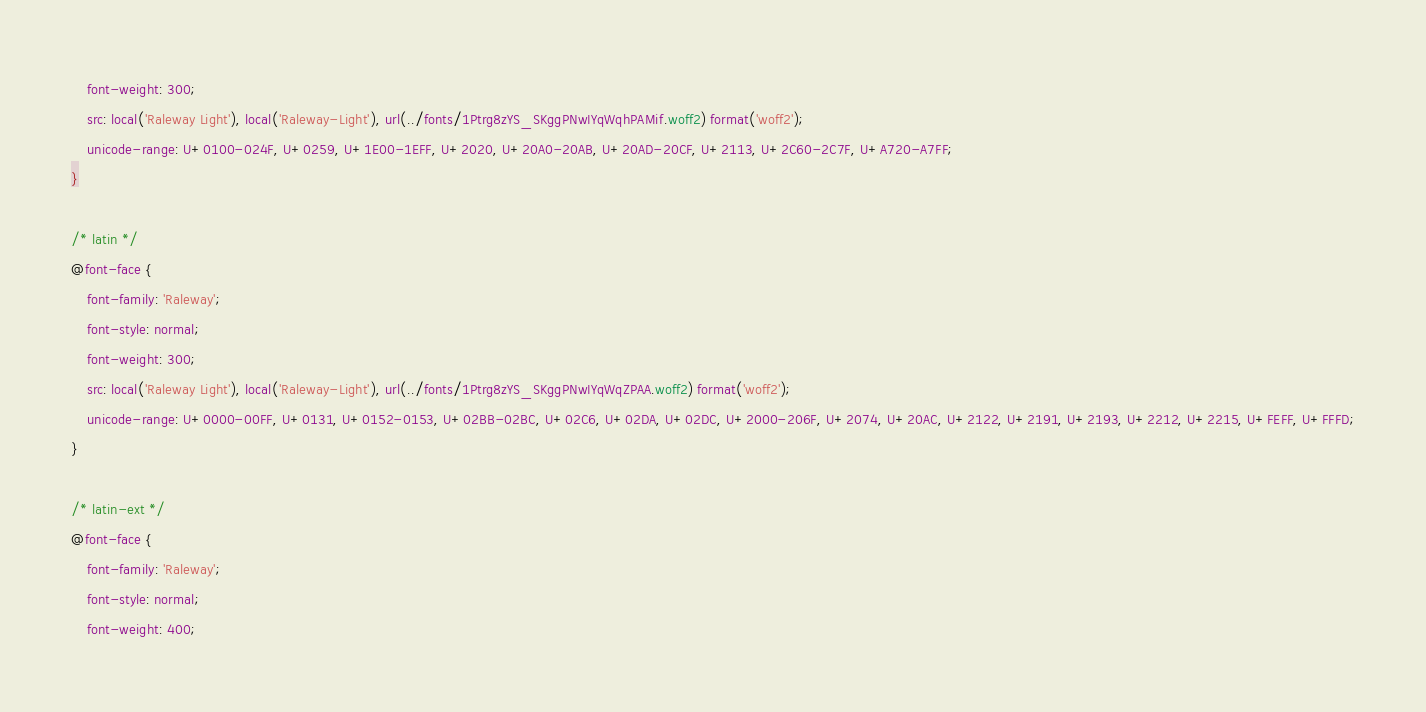Convert code to text. <code><loc_0><loc_0><loc_500><loc_500><_CSS_>    font-weight: 300;
    src: local('Raleway Light'), local('Raleway-Light'), url(../fonts/1Ptrg8zYS_SKggPNwIYqWqhPAMif.woff2) format('woff2');
    unicode-range: U+0100-024F, U+0259, U+1E00-1EFF, U+2020, U+20A0-20AB, U+20AD-20CF, U+2113, U+2C60-2C7F, U+A720-A7FF;
}

/* latin */
@font-face {
    font-family: 'Raleway';
    font-style: normal;
    font-weight: 300;
    src: local('Raleway Light'), local('Raleway-Light'), url(../fonts/1Ptrg8zYS_SKggPNwIYqWqZPAA.woff2) format('woff2');
    unicode-range: U+0000-00FF, U+0131, U+0152-0153, U+02BB-02BC, U+02C6, U+02DA, U+02DC, U+2000-206F, U+2074, U+20AC, U+2122, U+2191, U+2193, U+2212, U+2215, U+FEFF, U+FFFD;
}

/* latin-ext */
@font-face {
    font-family: 'Raleway';
    font-style: normal;
    font-weight: 400;</code> 